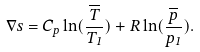<formula> <loc_0><loc_0><loc_500><loc_500>\nabla s = C _ { p } \ln ( { \frac { \overline { T } } { T _ { 1 } } } ) + R \ln ( { \frac { \overline { p } } { p _ { 1 } } } ) .</formula> 